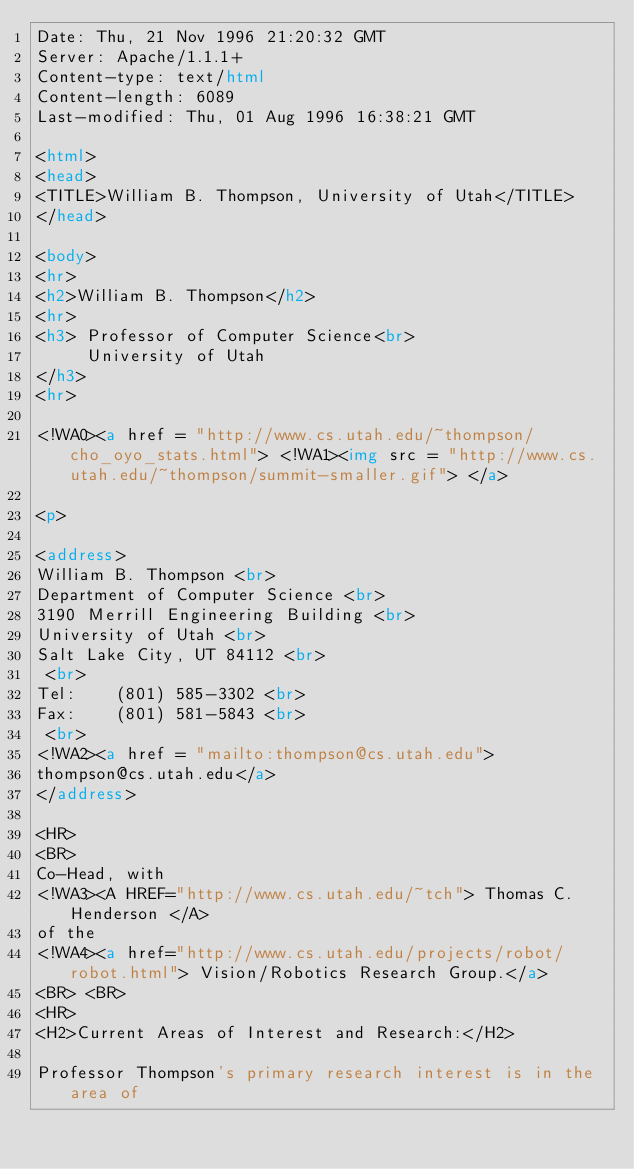Convert code to text. <code><loc_0><loc_0><loc_500><loc_500><_HTML_>Date: Thu, 21 Nov 1996 21:20:32 GMT
Server: Apache/1.1.1+
Content-type: text/html
Content-length: 6089
Last-modified: Thu, 01 Aug 1996 16:38:21 GMT

<html>
<head>
<TITLE>William B. Thompson, University of Utah</TITLE>
</head>

<body>
<hr>
<h2>William B. Thompson</h2>
<hr>
<h3> Professor of Computer Science<br>
     University of Utah
</h3>
<hr>

<!WA0><a href = "http://www.cs.utah.edu/~thompson/cho_oyo_stats.html"> <!WA1><img src = "http://www.cs.utah.edu/~thompson/summit-smaller.gif"> </a>

<p>

<address>
William B. Thompson <br>
Department of Computer Science <br>
3190 Merrill Engineering Building <br>
University of Utah <br>
Salt Lake City, UT 84112 <br>
 <br>
Tel:    (801) 585-3302 <br>
Fax:    (801) 581-5843 <br>
 <br>
<!WA2><a href = "mailto:thompson@cs.utah.edu">
thompson@cs.utah.edu</a>
</address>

<HR>
<BR>
Co-Head, with
<!WA3><A HREF="http://www.cs.utah.edu/~tch"> Thomas C. Henderson </A>
of the
<!WA4><a href="http://www.cs.utah.edu/projects/robot/robot.html"> Vision/Robotics Research Group.</a>
<BR> <BR>
<HR>
<H2>Current Areas of Interest and Research:</H2>

Professor Thompson's primary research interest is in the area of</code> 